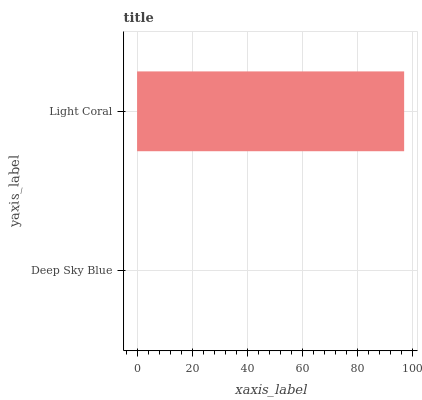Is Deep Sky Blue the minimum?
Answer yes or no. Yes. Is Light Coral the maximum?
Answer yes or no. Yes. Is Light Coral the minimum?
Answer yes or no. No. Is Light Coral greater than Deep Sky Blue?
Answer yes or no. Yes. Is Deep Sky Blue less than Light Coral?
Answer yes or no. Yes. Is Deep Sky Blue greater than Light Coral?
Answer yes or no. No. Is Light Coral less than Deep Sky Blue?
Answer yes or no. No. Is Light Coral the high median?
Answer yes or no. Yes. Is Deep Sky Blue the low median?
Answer yes or no. Yes. Is Deep Sky Blue the high median?
Answer yes or no. No. Is Light Coral the low median?
Answer yes or no. No. 